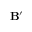Convert formula to latex. <formula><loc_0><loc_0><loc_500><loc_500>B ^ { \prime }</formula> 